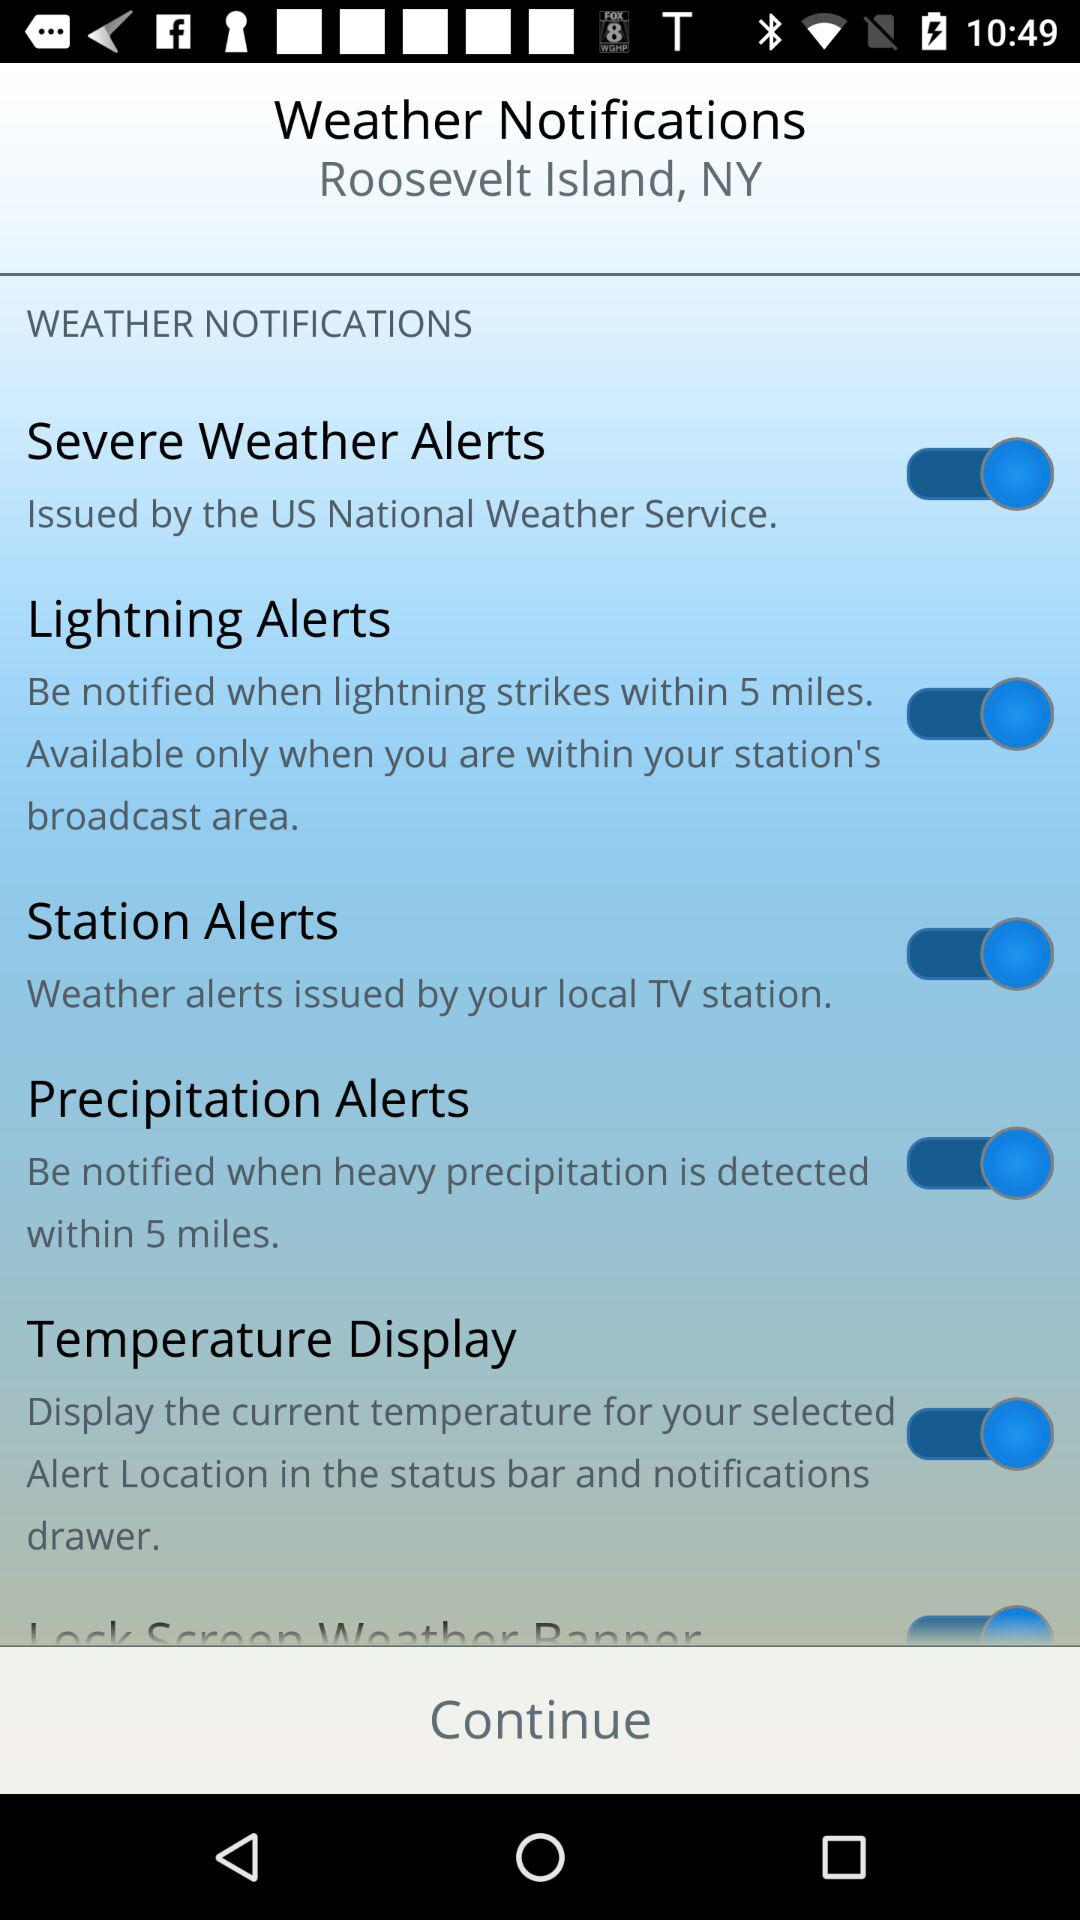What is the status of the "Precipitation Alerts" notification setting? The status of the "Precipitation Alerts" is "on". 